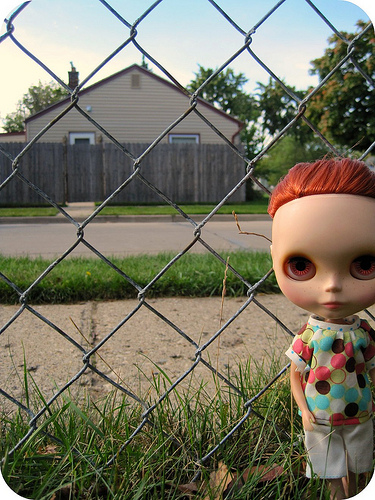<image>
Is there a doll in the grass? Yes. The doll is contained within or inside the grass, showing a containment relationship. 